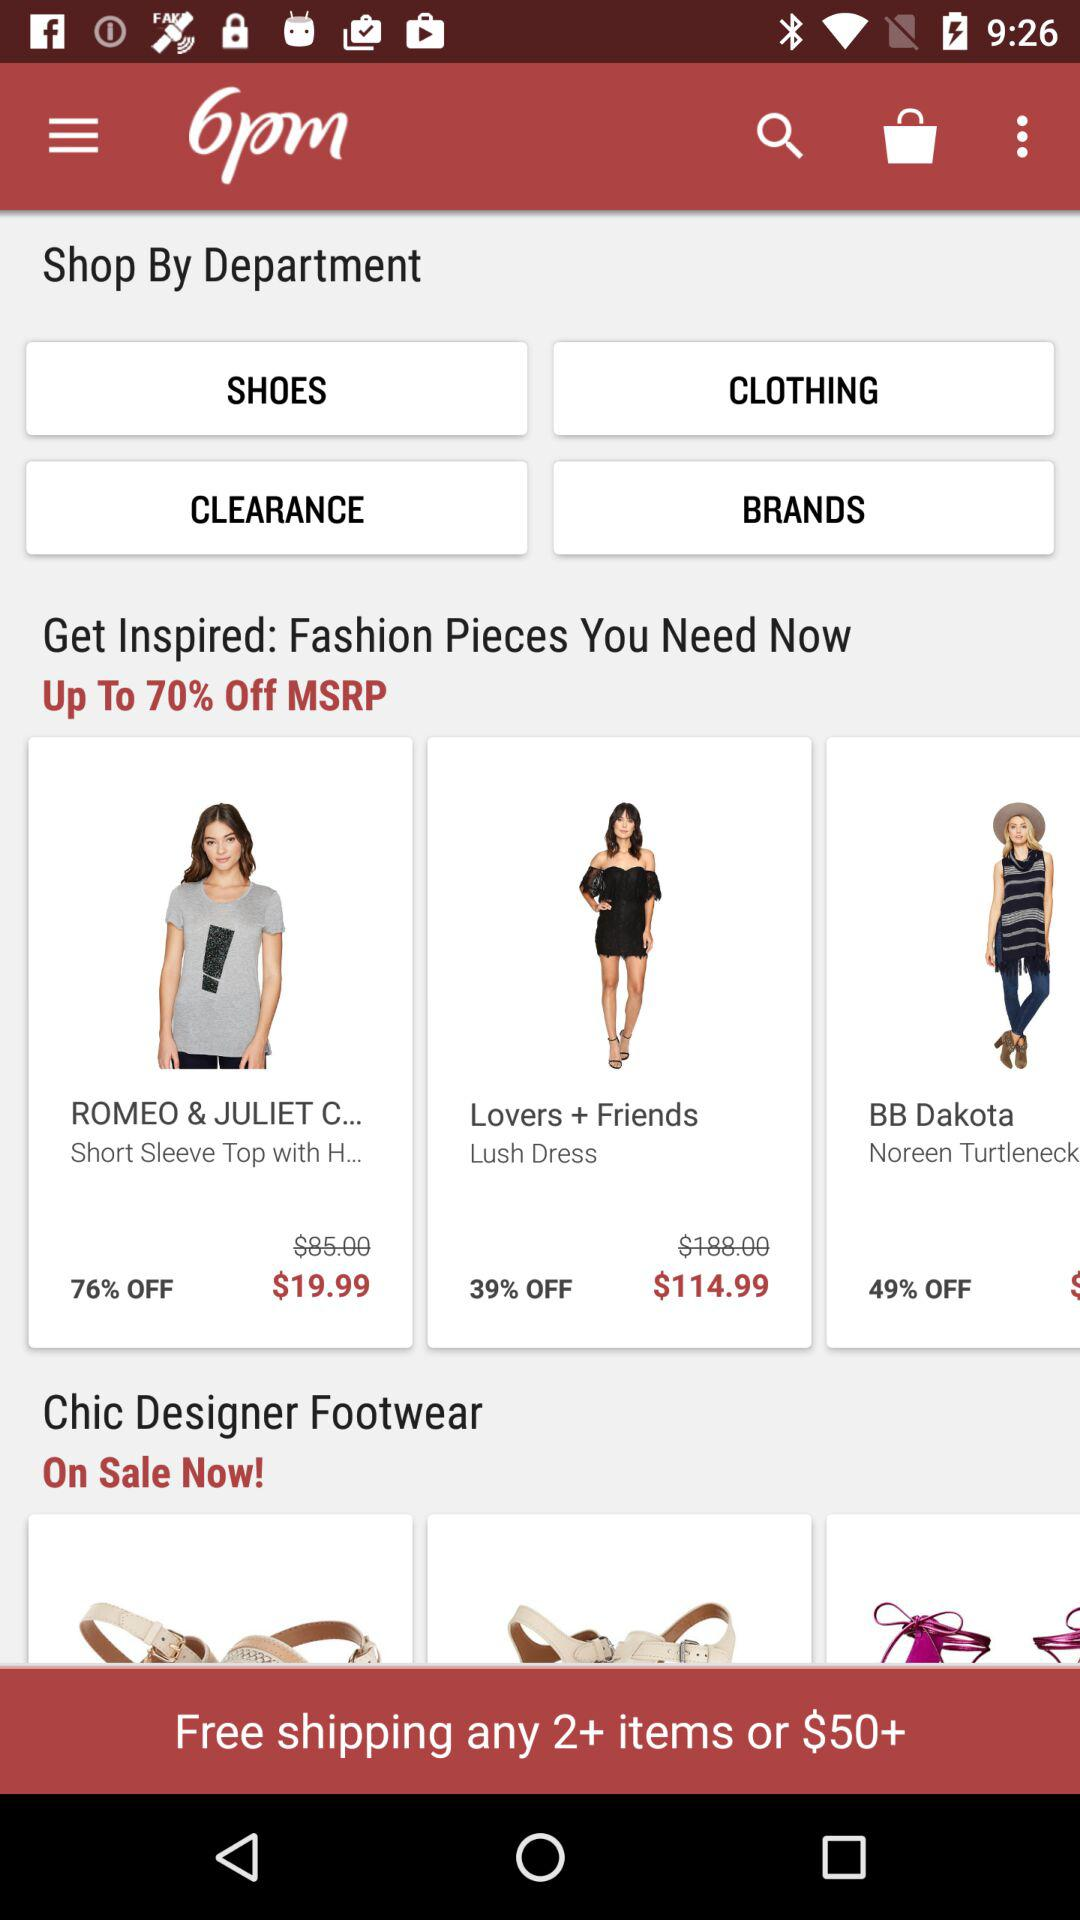How many items are on sale in the Chic Designer Footwear section?
Answer the question using a single word or phrase. 3 